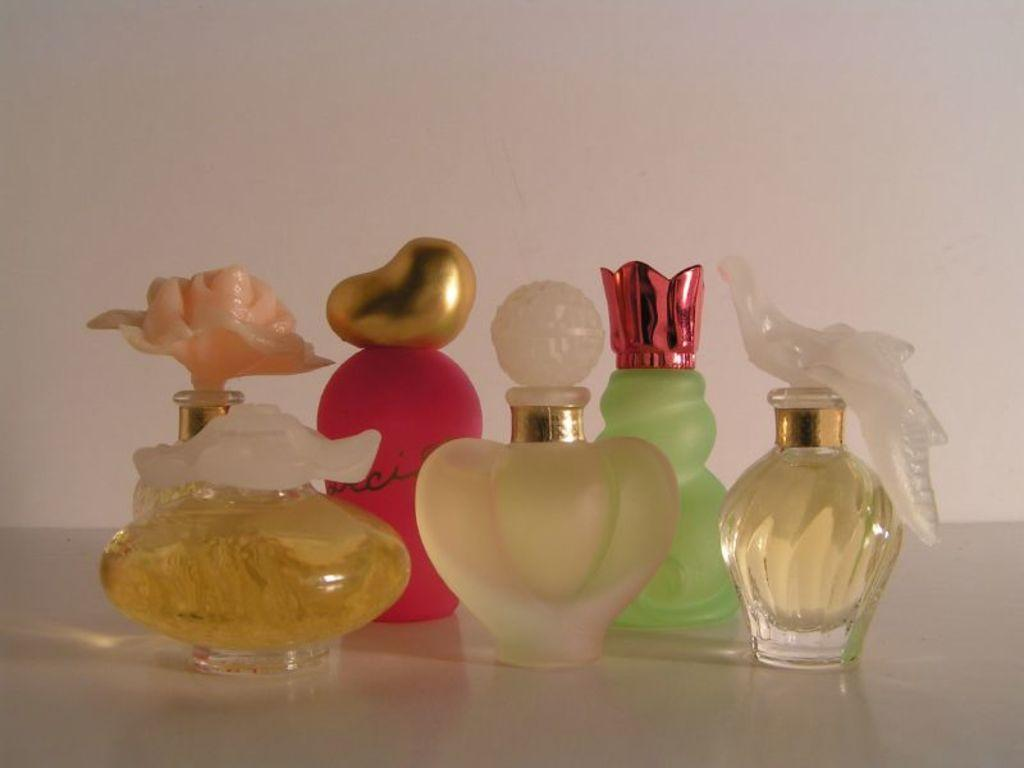What objects are on the surface in the image? There are bottles on the surface in the image. What can be seen in the background of the image? There is a wall in the background of the image. How many kittens are playing with a glove in the image? There are no kittens or gloves present in the image. What is the level of wealth depicted in the image? The image does not provide any information about wealth or financial status. 